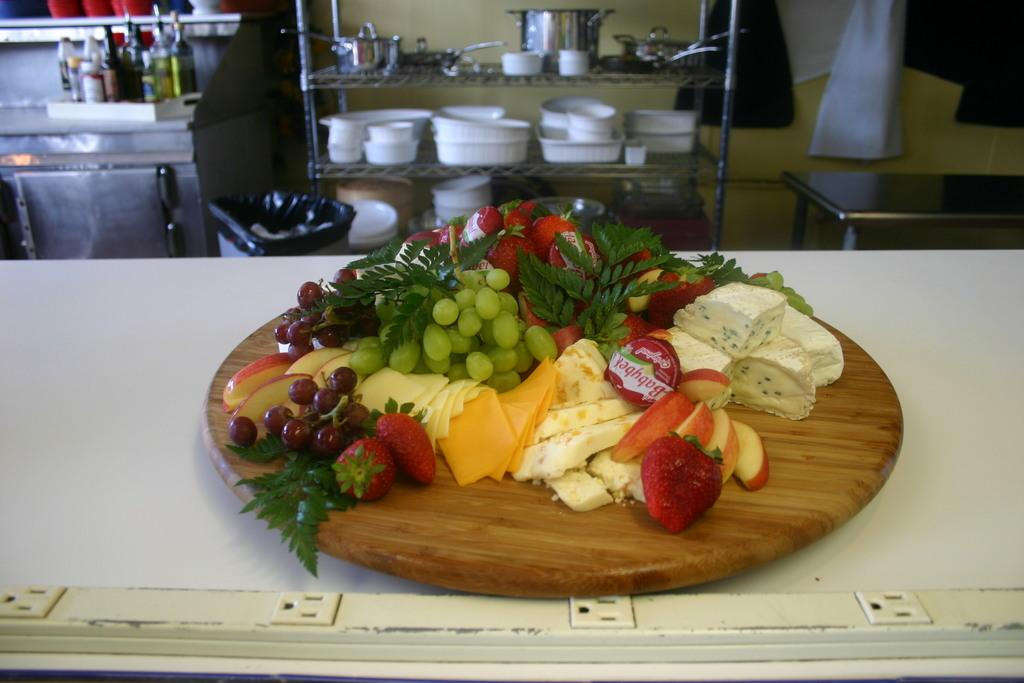What type of structure can be seen in the image? There is a wall in the image. What piece of furniture is present in the image? There is a table in the image. What is used for hanging or storing items in the image? There is a rack in the image. What type of containers are visible in the image? There are bowls in the image. What type of liquid-containing vessels are present in the image? There are bottles in the image. What type of food items can be seen in the image? There are different types of fruits in the image. What is the office environment like in the image? There is no mention of an office environment in the image; it features a wall, table, rack, bowls, bottles, and fruits. How many drops of water can be seen falling from the ceiling in the image? There is no mention of water or drops in the image; it only features the items listed in the facts. 